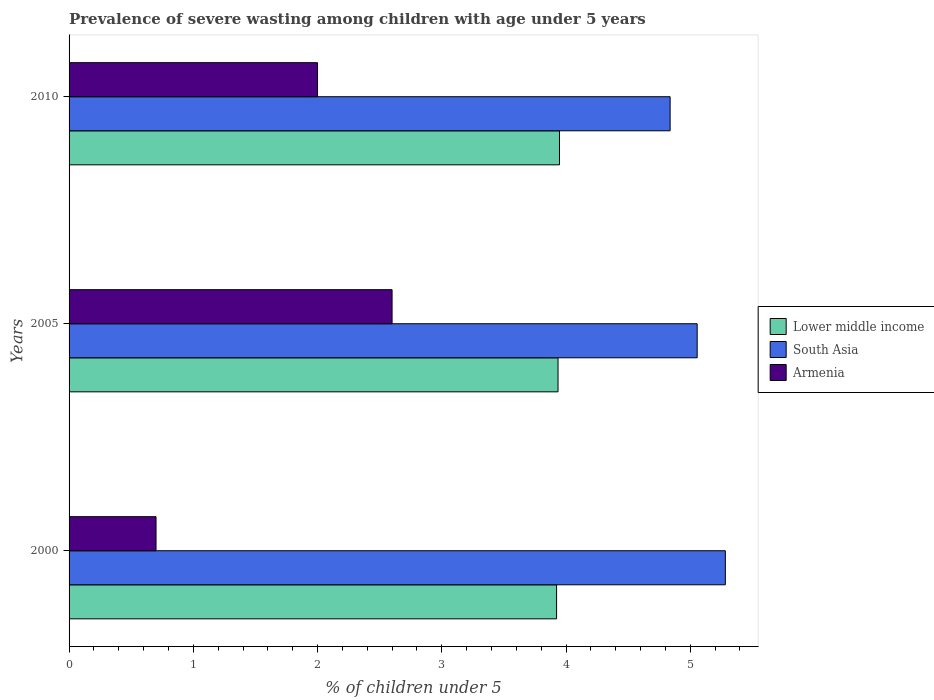Are the number of bars per tick equal to the number of legend labels?
Your answer should be compact. Yes. What is the label of the 3rd group of bars from the top?
Provide a short and direct response. 2000. In how many cases, is the number of bars for a given year not equal to the number of legend labels?
Provide a succinct answer. 0. What is the percentage of severely wasted children in South Asia in 2010?
Make the answer very short. 4.84. Across all years, what is the maximum percentage of severely wasted children in Lower middle income?
Your response must be concise. 3.95. Across all years, what is the minimum percentage of severely wasted children in Lower middle income?
Give a very brief answer. 3.92. In which year was the percentage of severely wasted children in South Asia minimum?
Give a very brief answer. 2010. What is the total percentage of severely wasted children in Armenia in the graph?
Provide a short and direct response. 5.3. What is the difference between the percentage of severely wasted children in Lower middle income in 2000 and that in 2005?
Your response must be concise. -0.01. What is the difference between the percentage of severely wasted children in Armenia in 2005 and the percentage of severely wasted children in Lower middle income in 2000?
Your response must be concise. -1.32. What is the average percentage of severely wasted children in Armenia per year?
Provide a short and direct response. 1.77. In the year 2010, what is the difference between the percentage of severely wasted children in South Asia and percentage of severely wasted children in Lower middle income?
Make the answer very short. 0.89. In how many years, is the percentage of severely wasted children in Lower middle income greater than 1.4 %?
Give a very brief answer. 3. What is the ratio of the percentage of severely wasted children in South Asia in 2000 to that in 2005?
Make the answer very short. 1.04. Is the percentage of severely wasted children in South Asia in 2000 less than that in 2005?
Ensure brevity in your answer.  No. Is the difference between the percentage of severely wasted children in South Asia in 2000 and 2005 greater than the difference between the percentage of severely wasted children in Lower middle income in 2000 and 2005?
Your answer should be very brief. Yes. What is the difference between the highest and the second highest percentage of severely wasted children in Lower middle income?
Provide a succinct answer. 0.01. What is the difference between the highest and the lowest percentage of severely wasted children in South Asia?
Provide a short and direct response. 0.44. In how many years, is the percentage of severely wasted children in Armenia greater than the average percentage of severely wasted children in Armenia taken over all years?
Provide a short and direct response. 2. Is the sum of the percentage of severely wasted children in Armenia in 2000 and 2010 greater than the maximum percentage of severely wasted children in South Asia across all years?
Provide a succinct answer. No. What does the 3rd bar from the top in 2010 represents?
Offer a terse response. Lower middle income. What does the 1st bar from the bottom in 2010 represents?
Your answer should be very brief. Lower middle income. Are all the bars in the graph horizontal?
Give a very brief answer. Yes. Does the graph contain any zero values?
Give a very brief answer. No. How are the legend labels stacked?
Ensure brevity in your answer.  Vertical. What is the title of the graph?
Offer a terse response. Prevalence of severe wasting among children with age under 5 years. What is the label or title of the X-axis?
Give a very brief answer. % of children under 5. What is the % of children under 5 of Lower middle income in 2000?
Provide a succinct answer. 3.92. What is the % of children under 5 in South Asia in 2000?
Offer a terse response. 5.28. What is the % of children under 5 in Armenia in 2000?
Your response must be concise. 0.7. What is the % of children under 5 of Lower middle income in 2005?
Offer a very short reply. 3.94. What is the % of children under 5 in South Asia in 2005?
Give a very brief answer. 5.06. What is the % of children under 5 of Armenia in 2005?
Your response must be concise. 2.6. What is the % of children under 5 of Lower middle income in 2010?
Ensure brevity in your answer.  3.95. What is the % of children under 5 of South Asia in 2010?
Offer a very short reply. 4.84. What is the % of children under 5 in Armenia in 2010?
Offer a terse response. 2. Across all years, what is the maximum % of children under 5 of Lower middle income?
Make the answer very short. 3.95. Across all years, what is the maximum % of children under 5 of South Asia?
Offer a very short reply. 5.28. Across all years, what is the maximum % of children under 5 in Armenia?
Make the answer very short. 2.6. Across all years, what is the minimum % of children under 5 in Lower middle income?
Ensure brevity in your answer.  3.92. Across all years, what is the minimum % of children under 5 of South Asia?
Keep it short and to the point. 4.84. Across all years, what is the minimum % of children under 5 of Armenia?
Provide a succinct answer. 0.7. What is the total % of children under 5 in Lower middle income in the graph?
Provide a succinct answer. 11.81. What is the total % of children under 5 in South Asia in the graph?
Give a very brief answer. 15.18. What is the total % of children under 5 of Armenia in the graph?
Offer a very short reply. 5.3. What is the difference between the % of children under 5 in Lower middle income in 2000 and that in 2005?
Ensure brevity in your answer.  -0.01. What is the difference between the % of children under 5 of South Asia in 2000 and that in 2005?
Your answer should be compact. 0.23. What is the difference between the % of children under 5 of Lower middle income in 2000 and that in 2010?
Offer a terse response. -0.02. What is the difference between the % of children under 5 in South Asia in 2000 and that in 2010?
Offer a terse response. 0.44. What is the difference between the % of children under 5 of Lower middle income in 2005 and that in 2010?
Offer a very short reply. -0.01. What is the difference between the % of children under 5 in South Asia in 2005 and that in 2010?
Provide a succinct answer. 0.22. What is the difference between the % of children under 5 of Armenia in 2005 and that in 2010?
Give a very brief answer. 0.6. What is the difference between the % of children under 5 of Lower middle income in 2000 and the % of children under 5 of South Asia in 2005?
Your answer should be very brief. -1.13. What is the difference between the % of children under 5 of Lower middle income in 2000 and the % of children under 5 of Armenia in 2005?
Your answer should be very brief. 1.32. What is the difference between the % of children under 5 of South Asia in 2000 and the % of children under 5 of Armenia in 2005?
Your answer should be compact. 2.68. What is the difference between the % of children under 5 of Lower middle income in 2000 and the % of children under 5 of South Asia in 2010?
Your answer should be compact. -0.91. What is the difference between the % of children under 5 of Lower middle income in 2000 and the % of children under 5 of Armenia in 2010?
Your answer should be compact. 1.92. What is the difference between the % of children under 5 in South Asia in 2000 and the % of children under 5 in Armenia in 2010?
Ensure brevity in your answer.  3.28. What is the difference between the % of children under 5 of Lower middle income in 2005 and the % of children under 5 of South Asia in 2010?
Ensure brevity in your answer.  -0.9. What is the difference between the % of children under 5 in Lower middle income in 2005 and the % of children under 5 in Armenia in 2010?
Your answer should be very brief. 1.94. What is the difference between the % of children under 5 in South Asia in 2005 and the % of children under 5 in Armenia in 2010?
Provide a succinct answer. 3.06. What is the average % of children under 5 in Lower middle income per year?
Ensure brevity in your answer.  3.94. What is the average % of children under 5 of South Asia per year?
Ensure brevity in your answer.  5.06. What is the average % of children under 5 in Armenia per year?
Provide a succinct answer. 1.77. In the year 2000, what is the difference between the % of children under 5 in Lower middle income and % of children under 5 in South Asia?
Offer a terse response. -1.36. In the year 2000, what is the difference between the % of children under 5 of Lower middle income and % of children under 5 of Armenia?
Your answer should be very brief. 3.22. In the year 2000, what is the difference between the % of children under 5 of South Asia and % of children under 5 of Armenia?
Your answer should be very brief. 4.58. In the year 2005, what is the difference between the % of children under 5 in Lower middle income and % of children under 5 in South Asia?
Your response must be concise. -1.12. In the year 2005, what is the difference between the % of children under 5 of Lower middle income and % of children under 5 of Armenia?
Offer a terse response. 1.34. In the year 2005, what is the difference between the % of children under 5 in South Asia and % of children under 5 in Armenia?
Keep it short and to the point. 2.46. In the year 2010, what is the difference between the % of children under 5 in Lower middle income and % of children under 5 in South Asia?
Ensure brevity in your answer.  -0.89. In the year 2010, what is the difference between the % of children under 5 in Lower middle income and % of children under 5 in Armenia?
Offer a terse response. 1.95. In the year 2010, what is the difference between the % of children under 5 of South Asia and % of children under 5 of Armenia?
Your response must be concise. 2.84. What is the ratio of the % of children under 5 in South Asia in 2000 to that in 2005?
Your response must be concise. 1.04. What is the ratio of the % of children under 5 in Armenia in 2000 to that in 2005?
Offer a very short reply. 0.27. What is the ratio of the % of children under 5 of Lower middle income in 2000 to that in 2010?
Make the answer very short. 0.99. What is the ratio of the % of children under 5 in South Asia in 2000 to that in 2010?
Provide a succinct answer. 1.09. What is the ratio of the % of children under 5 of South Asia in 2005 to that in 2010?
Offer a very short reply. 1.04. What is the ratio of the % of children under 5 in Armenia in 2005 to that in 2010?
Provide a succinct answer. 1.3. What is the difference between the highest and the second highest % of children under 5 in Lower middle income?
Give a very brief answer. 0.01. What is the difference between the highest and the second highest % of children under 5 of South Asia?
Keep it short and to the point. 0.23. What is the difference between the highest and the lowest % of children under 5 of Lower middle income?
Offer a very short reply. 0.02. What is the difference between the highest and the lowest % of children under 5 in South Asia?
Provide a succinct answer. 0.44. What is the difference between the highest and the lowest % of children under 5 of Armenia?
Ensure brevity in your answer.  1.9. 